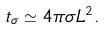Convert formula to latex. <formula><loc_0><loc_0><loc_500><loc_500>t _ { \sigma } \simeq 4 \pi \sigma L ^ { 2 } .</formula> 